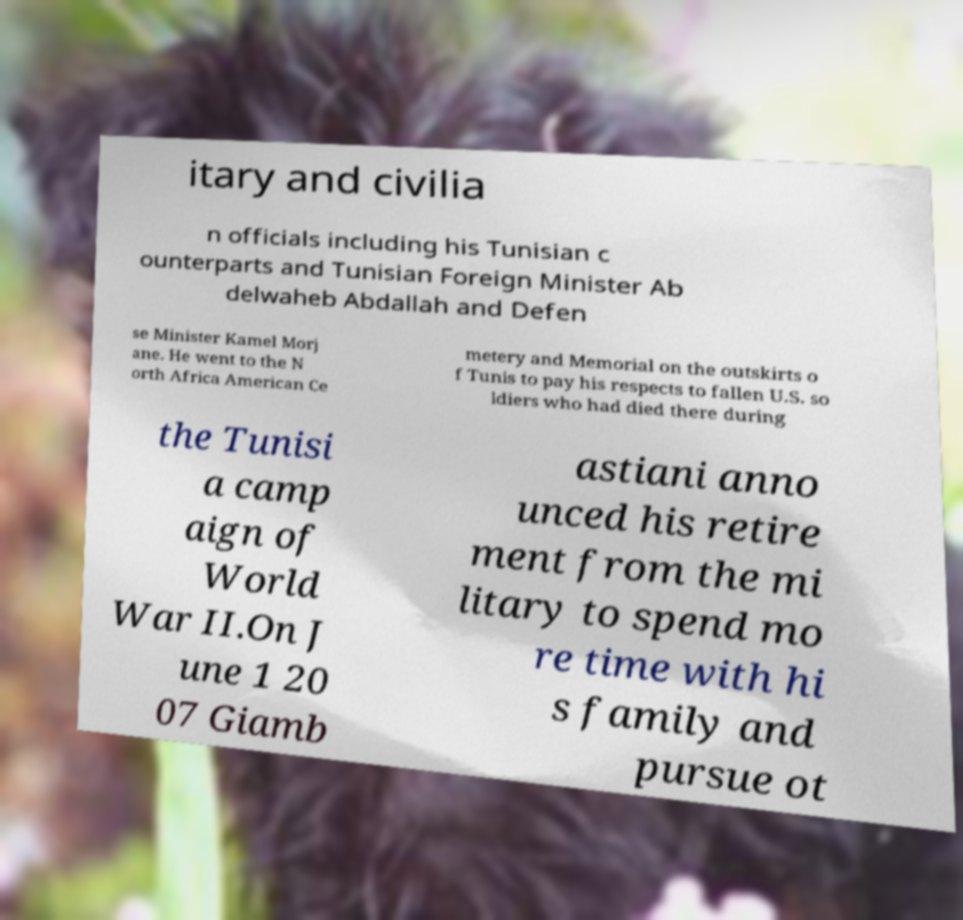For documentation purposes, I need the text within this image transcribed. Could you provide that? itary and civilia n officials including his Tunisian c ounterparts and Tunisian Foreign Minister Ab delwaheb Abdallah and Defen se Minister Kamel Morj ane. He went to the N orth Africa American Ce metery and Memorial on the outskirts o f Tunis to pay his respects to fallen U.S. so ldiers who had died there during the Tunisi a camp aign of World War II.On J une 1 20 07 Giamb astiani anno unced his retire ment from the mi litary to spend mo re time with hi s family and pursue ot 